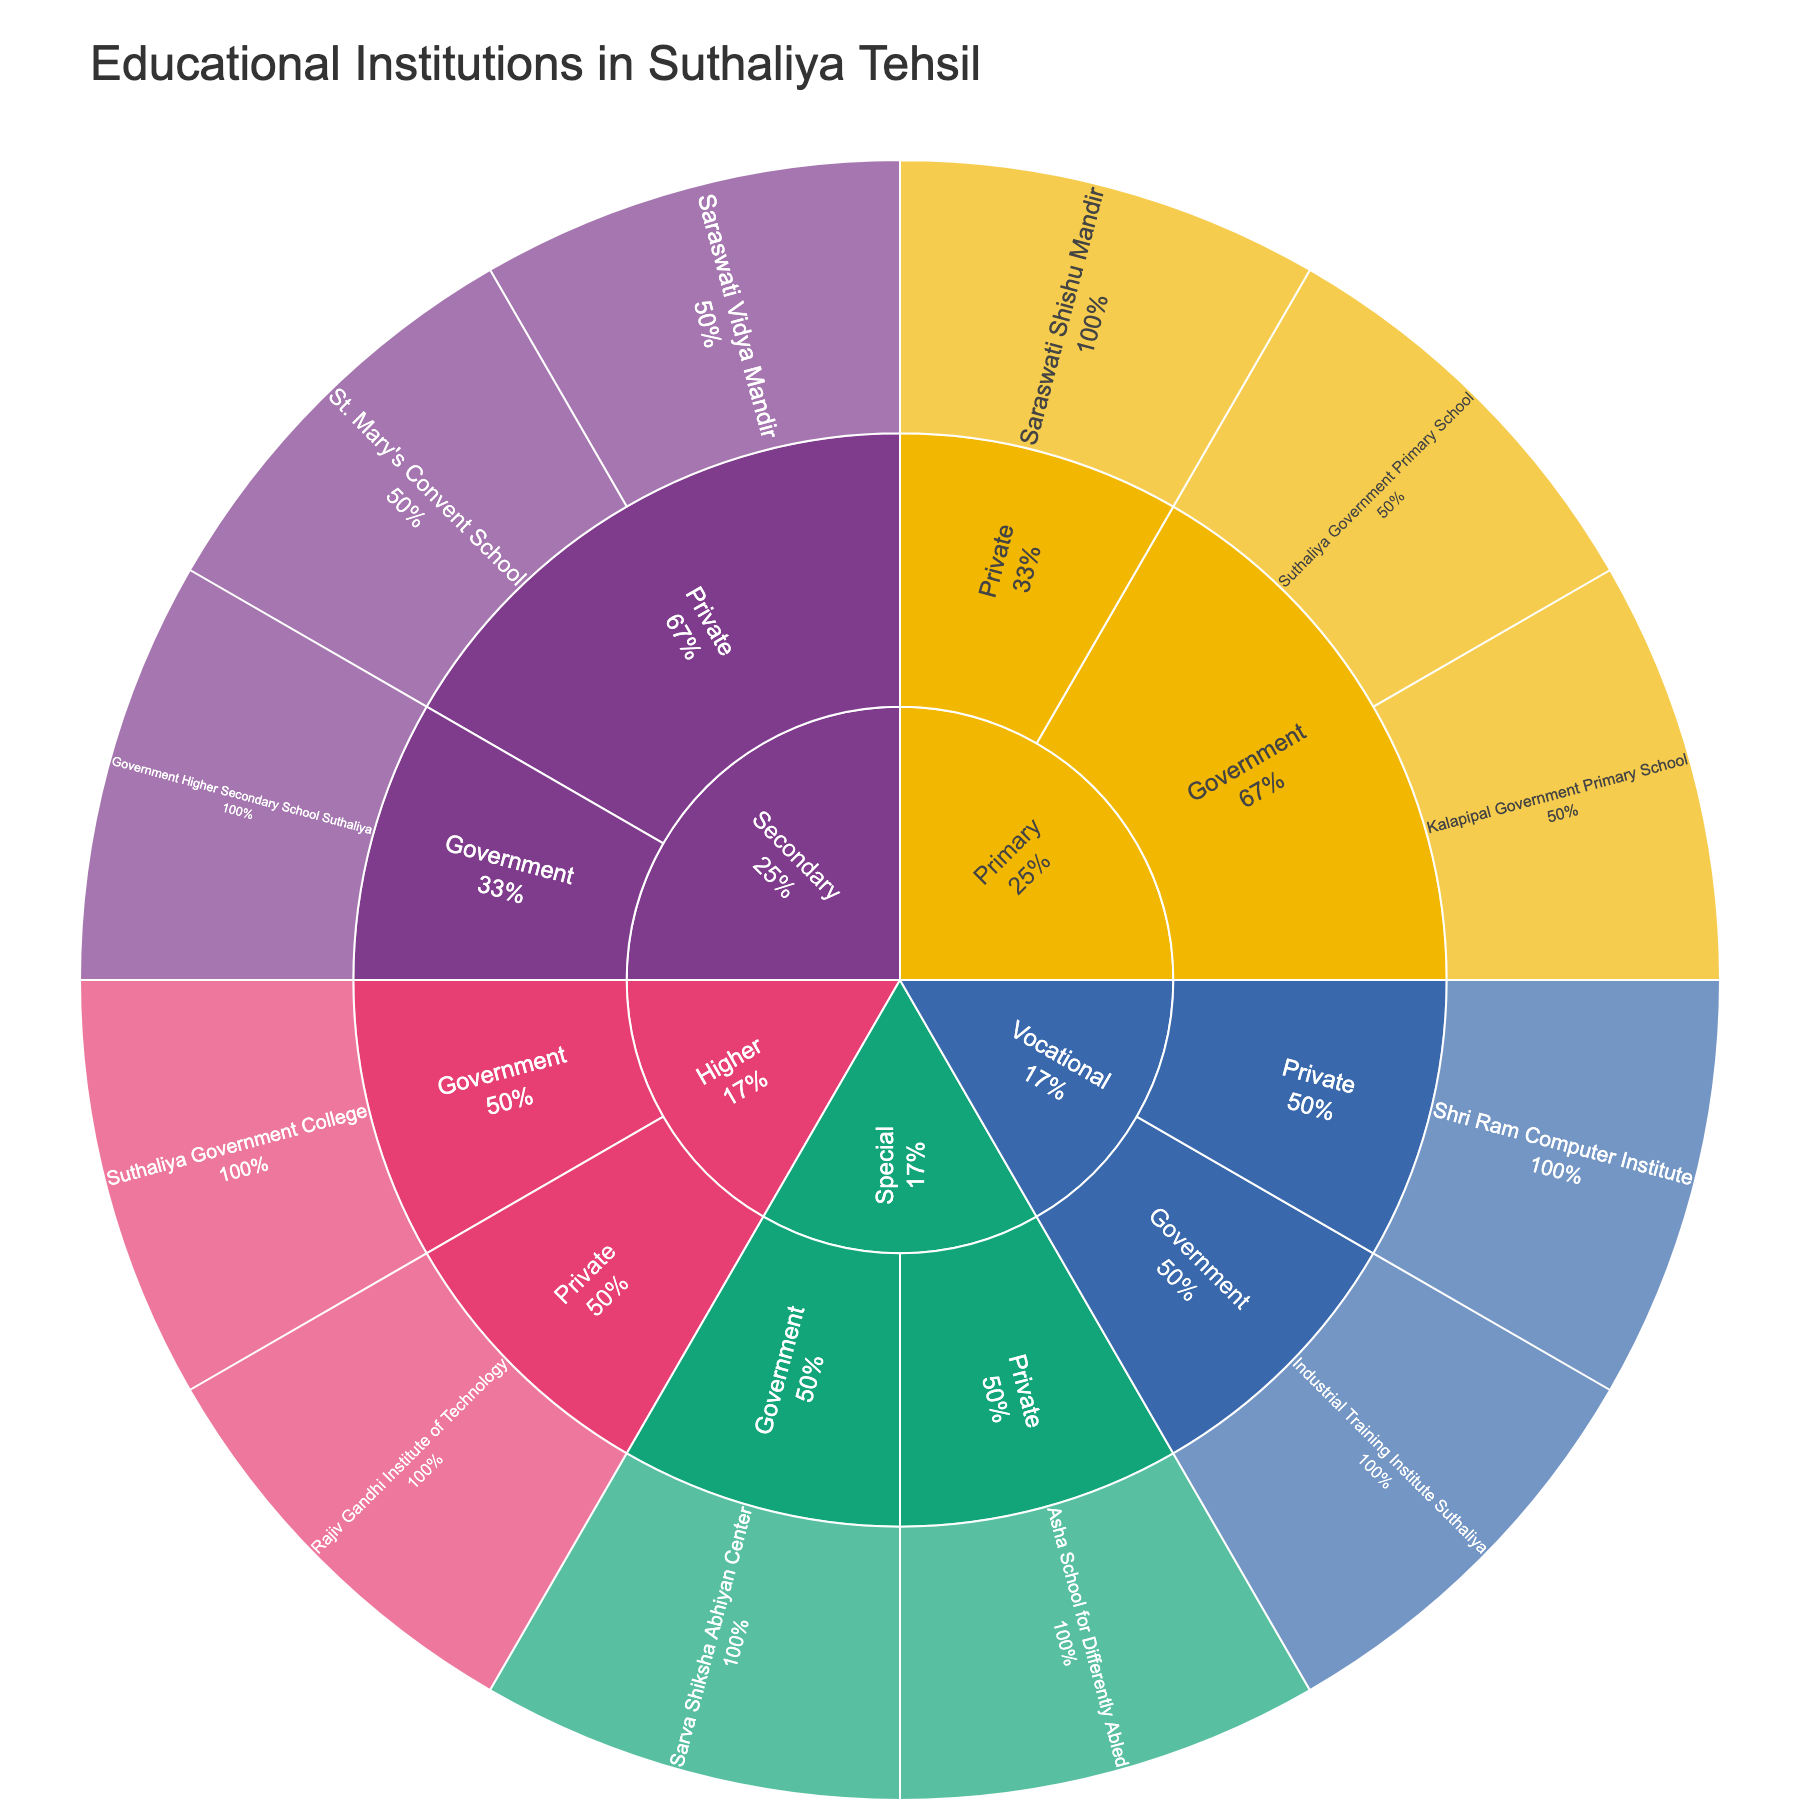How many types of educational institutions are represented in the plot? The plot has five main segments, which represent different levels of educational institutions: Primary, Secondary, Higher, Vocational, and Special.
Answer: 5 Which level has more private institutions: Secondary or Primary? The Secondary level has two private institutions (St. Mary's Convent School and Saraswati Vidya Mandir), while the Primary level has only one private institution (Saraswati Shishu Mandir).
Answer: Secondary How many government educational institutions are there in total? There are government institutions in each category: two in Primary, one in Secondary, one in Higher, one in Vocational, and one in Special. Adding these together, we get 2 + 1 + 1 + 1 + 1 = 6.
Answer: 6 What proportion of the Vocational institutions is private? There are two Vocational institutions, one Government (Industrial Training Institute Suthaliya) and one Private (Shri Ram Computer Institute). Thus, the proportion of private Vocational institutions is 1 out of 2, or 50%.
Answer: 50% Which has more institutions, Private Primary or Government Primary? There are two Government Primary institutions (Suthaliya Government Primary School and Kalapipal Government Primary School) and one Private Primary institution (Saraswati Shishu Mandir). Thus, Government Primary has more institutions.
Answer: Government Primary Are there more institutions managed by the government or privately overall? Summing up the institutions: Government (2 Primary + 1 Secondary + 1 Higher + 1 Vocational + 1 Special = 6) and Private (1 Primary + 2 Secondary + 1 Higher + 1 Vocational + 1 Special = 6). Both have the same number of institutions.
Answer: Same Which institution level is uniquely represented by only one management type? The Higher level has one institution per management type (Government and Private), thus not fitting. The Special level has one Government and one Private. The Primary, Secondary, and Vocational levels each have both types. Hence, there is no level uniquely represented by one management type.
Answer: None What is the representation of Special institutions? There are two Special institutions: one Government (Sarva Shiksha Abhiyan Center) and one Private (Asha School for Differently Abled).
Answer: 2 